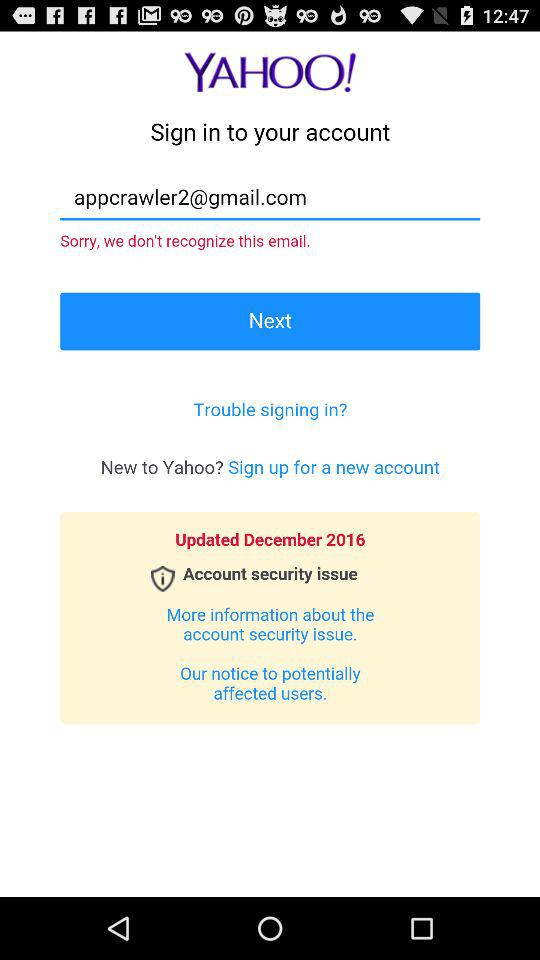What is the email address? The email address is appcrawler2@gmail.com. 